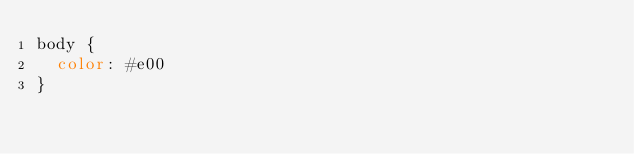<code> <loc_0><loc_0><loc_500><loc_500><_CSS_>body {
  color: #e00
}
</code> 